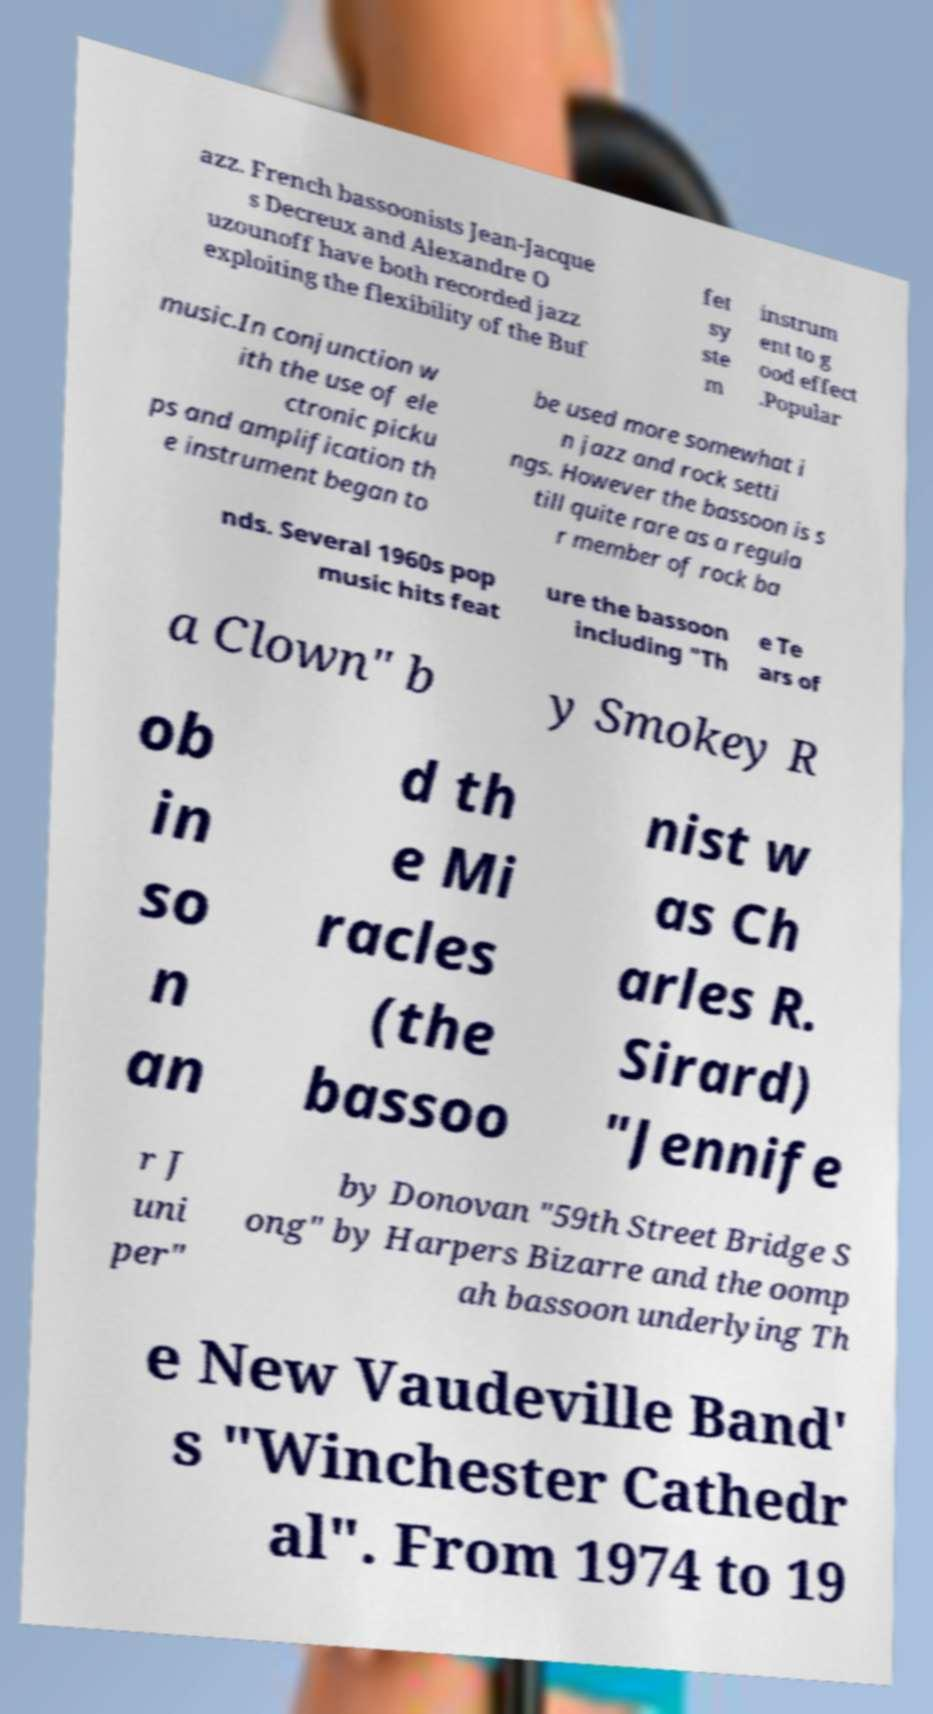For documentation purposes, I need the text within this image transcribed. Could you provide that? azz. French bassoonists Jean-Jacque s Decreux and Alexandre O uzounoff have both recorded jazz exploiting the flexibility of the Buf fet sy ste m instrum ent to g ood effect .Popular music.In conjunction w ith the use of ele ctronic picku ps and amplification th e instrument began to be used more somewhat i n jazz and rock setti ngs. However the bassoon is s till quite rare as a regula r member of rock ba nds. Several 1960s pop music hits feat ure the bassoon including "Th e Te ars of a Clown" b y Smokey R ob in so n an d th e Mi racles (the bassoo nist w as Ch arles R. Sirard) "Jennife r J uni per" by Donovan "59th Street Bridge S ong" by Harpers Bizarre and the oomp ah bassoon underlying Th e New Vaudeville Band' s "Winchester Cathedr al". From 1974 to 19 